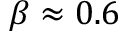<formula> <loc_0><loc_0><loc_500><loc_500>\beta \approx 0 . 6</formula> 